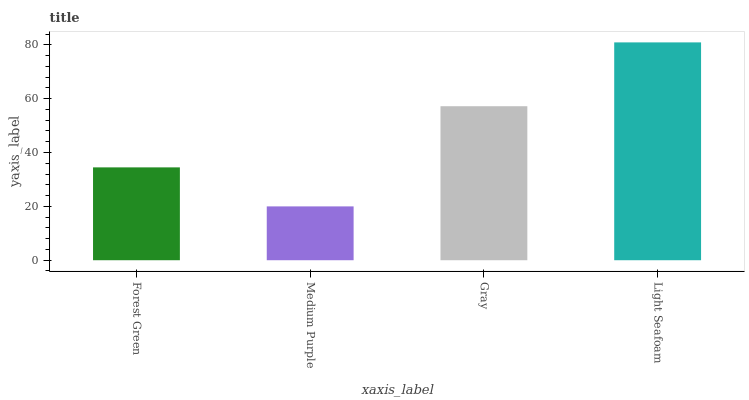Is Medium Purple the minimum?
Answer yes or no. Yes. Is Light Seafoam the maximum?
Answer yes or no. Yes. Is Gray the minimum?
Answer yes or no. No. Is Gray the maximum?
Answer yes or no. No. Is Gray greater than Medium Purple?
Answer yes or no. Yes. Is Medium Purple less than Gray?
Answer yes or no. Yes. Is Medium Purple greater than Gray?
Answer yes or no. No. Is Gray less than Medium Purple?
Answer yes or no. No. Is Gray the high median?
Answer yes or no. Yes. Is Forest Green the low median?
Answer yes or no. Yes. Is Forest Green the high median?
Answer yes or no. No. Is Medium Purple the low median?
Answer yes or no. No. 